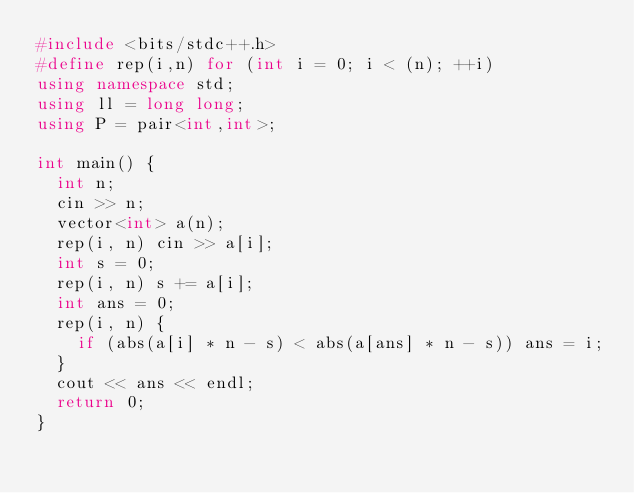Convert code to text. <code><loc_0><loc_0><loc_500><loc_500><_C++_>#include <bits/stdc++.h>
#define rep(i,n) for (int i = 0; i < (n); ++i)
using namespace std;
using ll = long long;
using P = pair<int,int>;

int main() {
  int n;
  cin >> n;
  vector<int> a(n);
  rep(i, n) cin >> a[i];
  int s = 0;
  rep(i, n) s += a[i];
  int ans = 0;
  rep(i, n) {
    if (abs(a[i] * n - s) < abs(a[ans] * n - s)) ans = i;
  }
  cout << ans << endl;
  return 0;
}</code> 